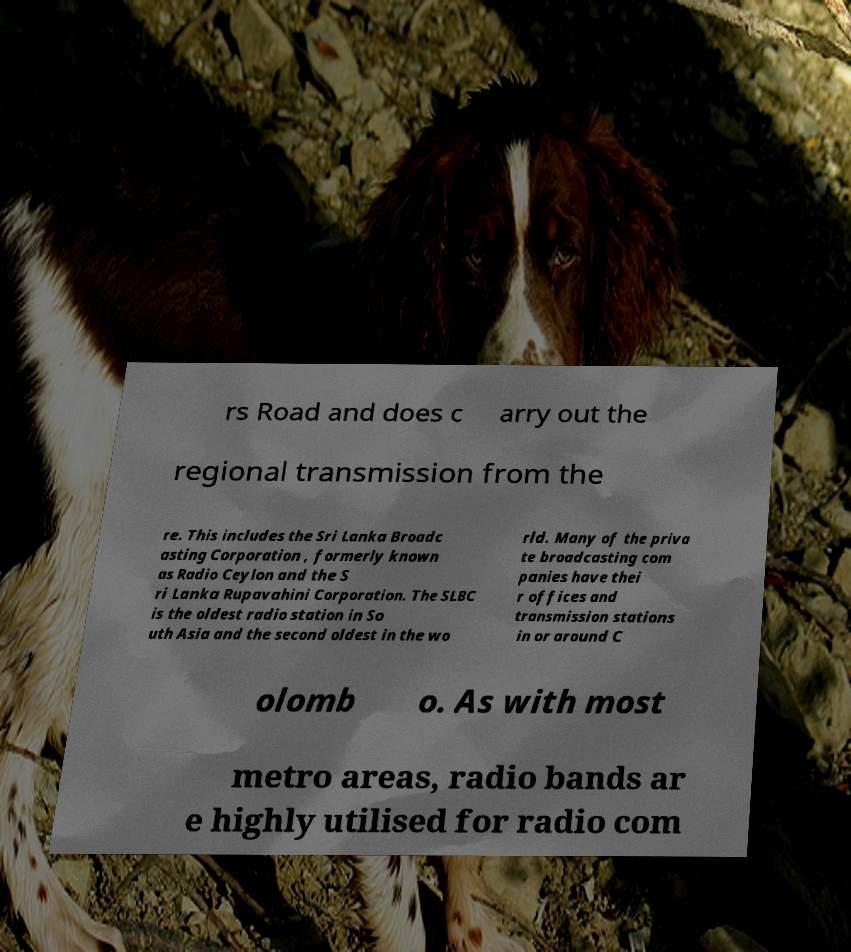Can you read and provide the text displayed in the image?This photo seems to have some interesting text. Can you extract and type it out for me? rs Road and does c arry out the regional transmission from the re. This includes the Sri Lanka Broadc asting Corporation , formerly known as Radio Ceylon and the S ri Lanka Rupavahini Corporation. The SLBC is the oldest radio station in So uth Asia and the second oldest in the wo rld. Many of the priva te broadcasting com panies have thei r offices and transmission stations in or around C olomb o. As with most metro areas, radio bands ar e highly utilised for radio com 